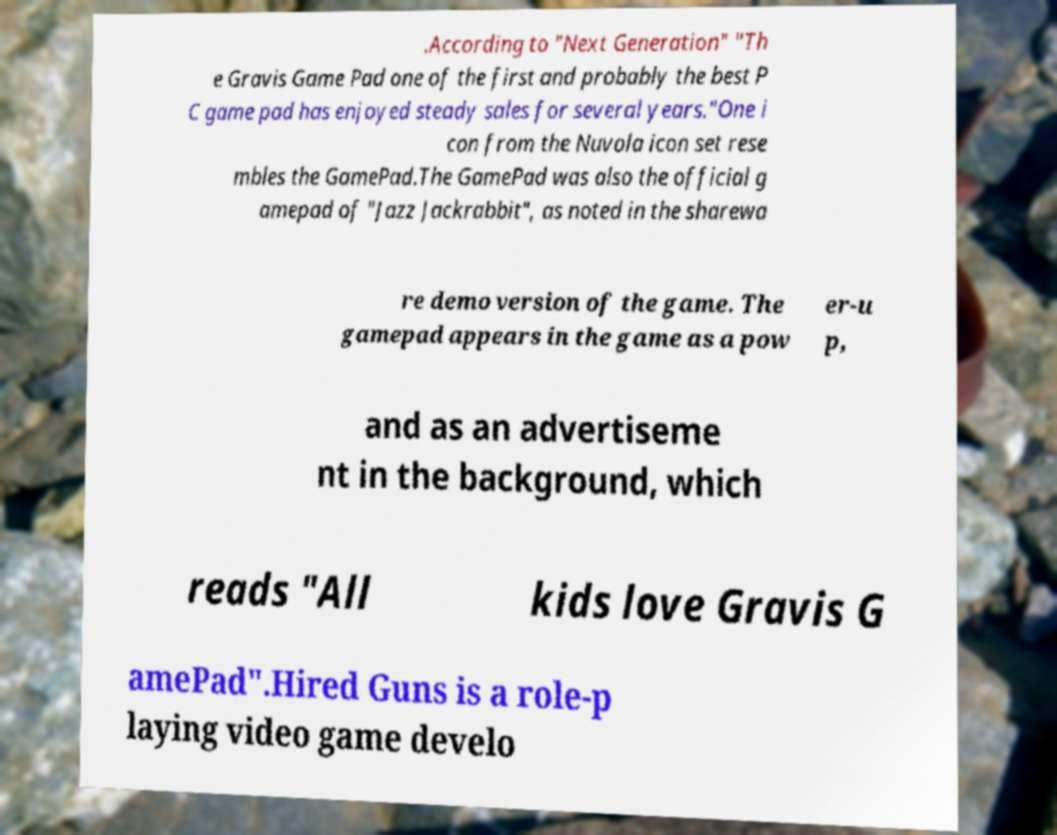For documentation purposes, I need the text within this image transcribed. Could you provide that? .According to "Next Generation" "Th e Gravis Game Pad one of the first and probably the best P C game pad has enjoyed steady sales for several years."One i con from the Nuvola icon set rese mbles the GamePad.The GamePad was also the official g amepad of "Jazz Jackrabbit", as noted in the sharewa re demo version of the game. The gamepad appears in the game as a pow er-u p, and as an advertiseme nt in the background, which reads "All kids love Gravis G amePad".Hired Guns is a role-p laying video game develo 